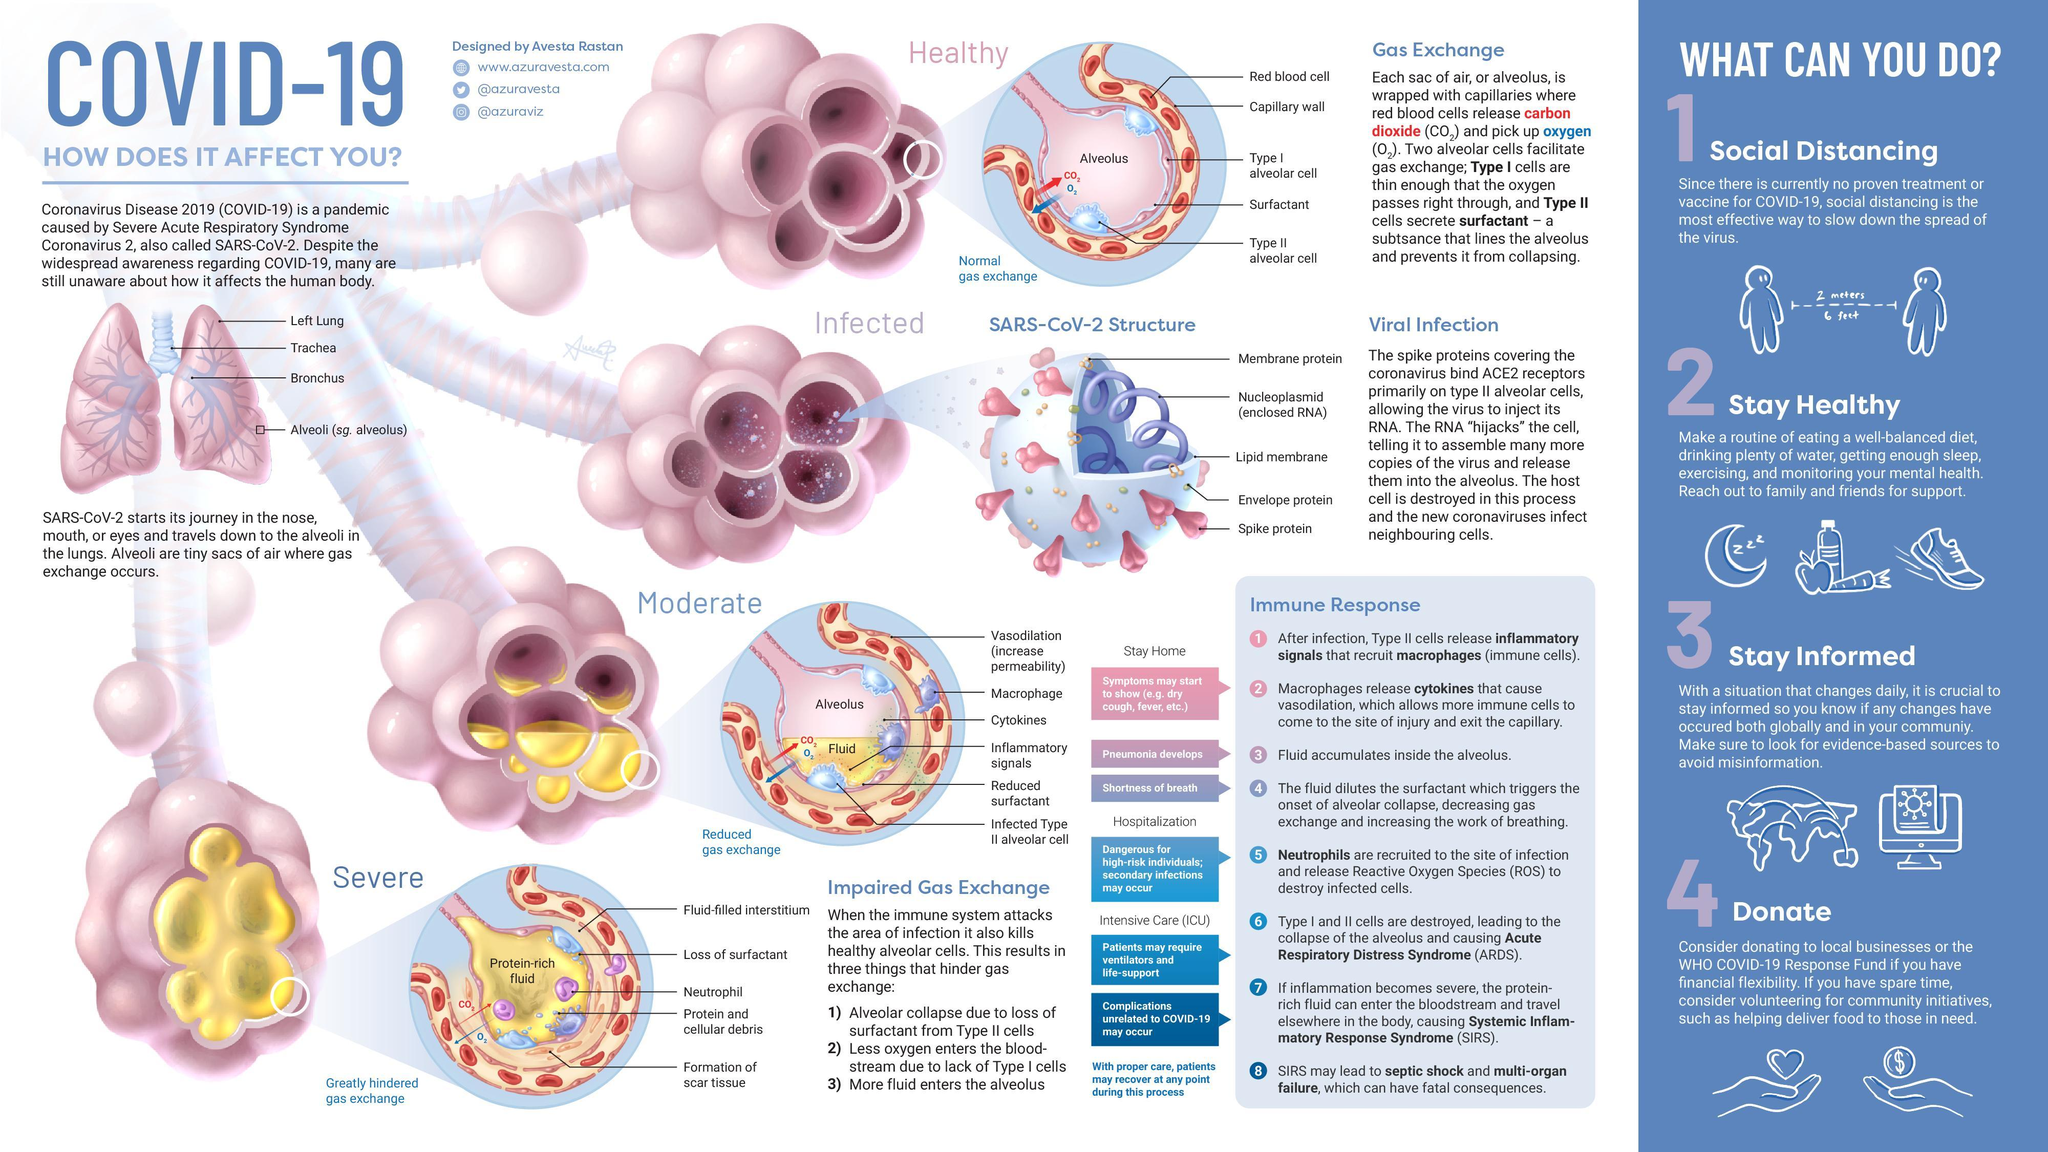What is the inner layer in the structure of SARS-COV-2 Virus?
Answer the question with a short phrase. Nucleoplasmid At which stage of infection, will the alveoli loose its surfactant completely - healthy, moderate or Severe? Severe What can you do if you have spare time? Consider volunteering for community initiatives What would be the most effective way to 'slow down the spread' of coronavirus? Social distancing At what stage of infection in the alveoli, will gas exchange be greatly hindered - moderate, severe or healthy? Severe Apart from social distancing what are the three other things you can do? Stay healthy, stay informed, donate What are the three proteins in the structure of a SARS-COV-2 virus? Membrane protein, Envelope protein, Spike protein What are the symptoms that 'may' develop when 'macrophages release cytokines that cause vasodilation' as an immune response? Dry cough, fever Which part of the lungs is infected by the coronavirus? Alveoli At what stage of infection in the alveoli, will there be 'reduced gas exchange' - moderate, severe or healthy? Moderate Which substance is responsible for protecting the alveoli from collapsing? Surfactant What is the body's next 'immune response', after the release of cytokines? Fluid accumulates inside the alveolus What are the two intensive care supports that a patient with ARDS may require? Ventilators and life-support What symptom develops when 'fluid accumulates inside the alveolus'? Pneumonia 